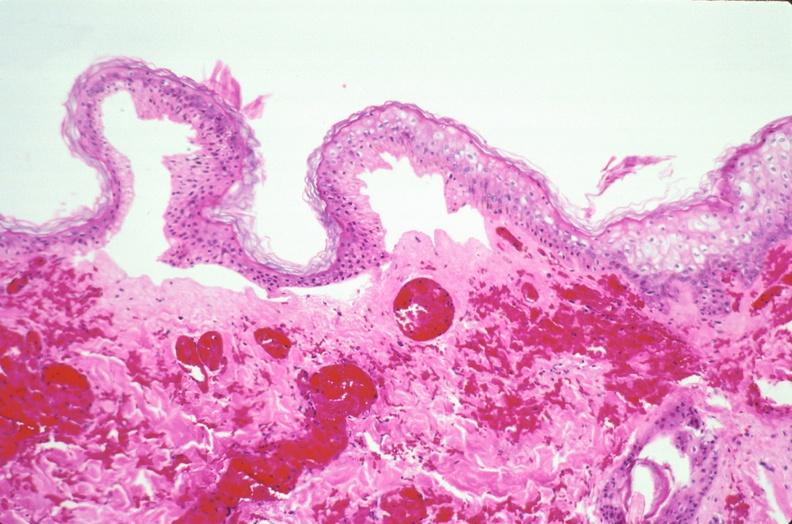does this image show skin, epidermolysis bullosa?
Answer the question using a single word or phrase. Yes 